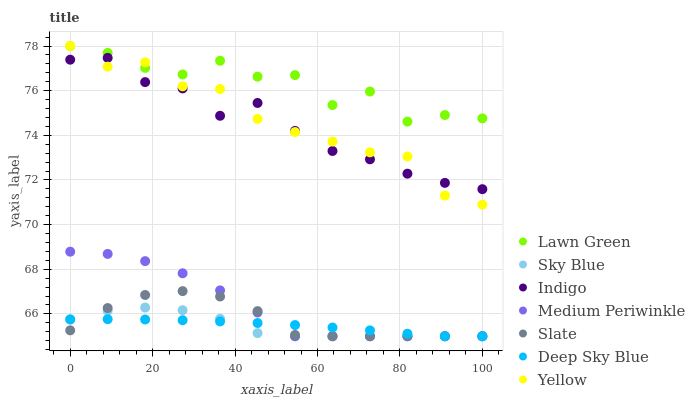Does Sky Blue have the minimum area under the curve?
Answer yes or no. Yes. Does Lawn Green have the maximum area under the curve?
Answer yes or no. Yes. Does Indigo have the minimum area under the curve?
Answer yes or no. No. Does Indigo have the maximum area under the curve?
Answer yes or no. No. Is Deep Sky Blue the smoothest?
Answer yes or no. Yes. Is Lawn Green the roughest?
Answer yes or no. Yes. Is Indigo the smoothest?
Answer yes or no. No. Is Indigo the roughest?
Answer yes or no. No. Does Slate have the lowest value?
Answer yes or no. Yes. Does Indigo have the lowest value?
Answer yes or no. No. Does Yellow have the highest value?
Answer yes or no. Yes. Does Indigo have the highest value?
Answer yes or no. No. Is Deep Sky Blue less than Lawn Green?
Answer yes or no. Yes. Is Indigo greater than Medium Periwinkle?
Answer yes or no. Yes. Does Slate intersect Medium Periwinkle?
Answer yes or no. Yes. Is Slate less than Medium Periwinkle?
Answer yes or no. No. Is Slate greater than Medium Periwinkle?
Answer yes or no. No. Does Deep Sky Blue intersect Lawn Green?
Answer yes or no. No. 